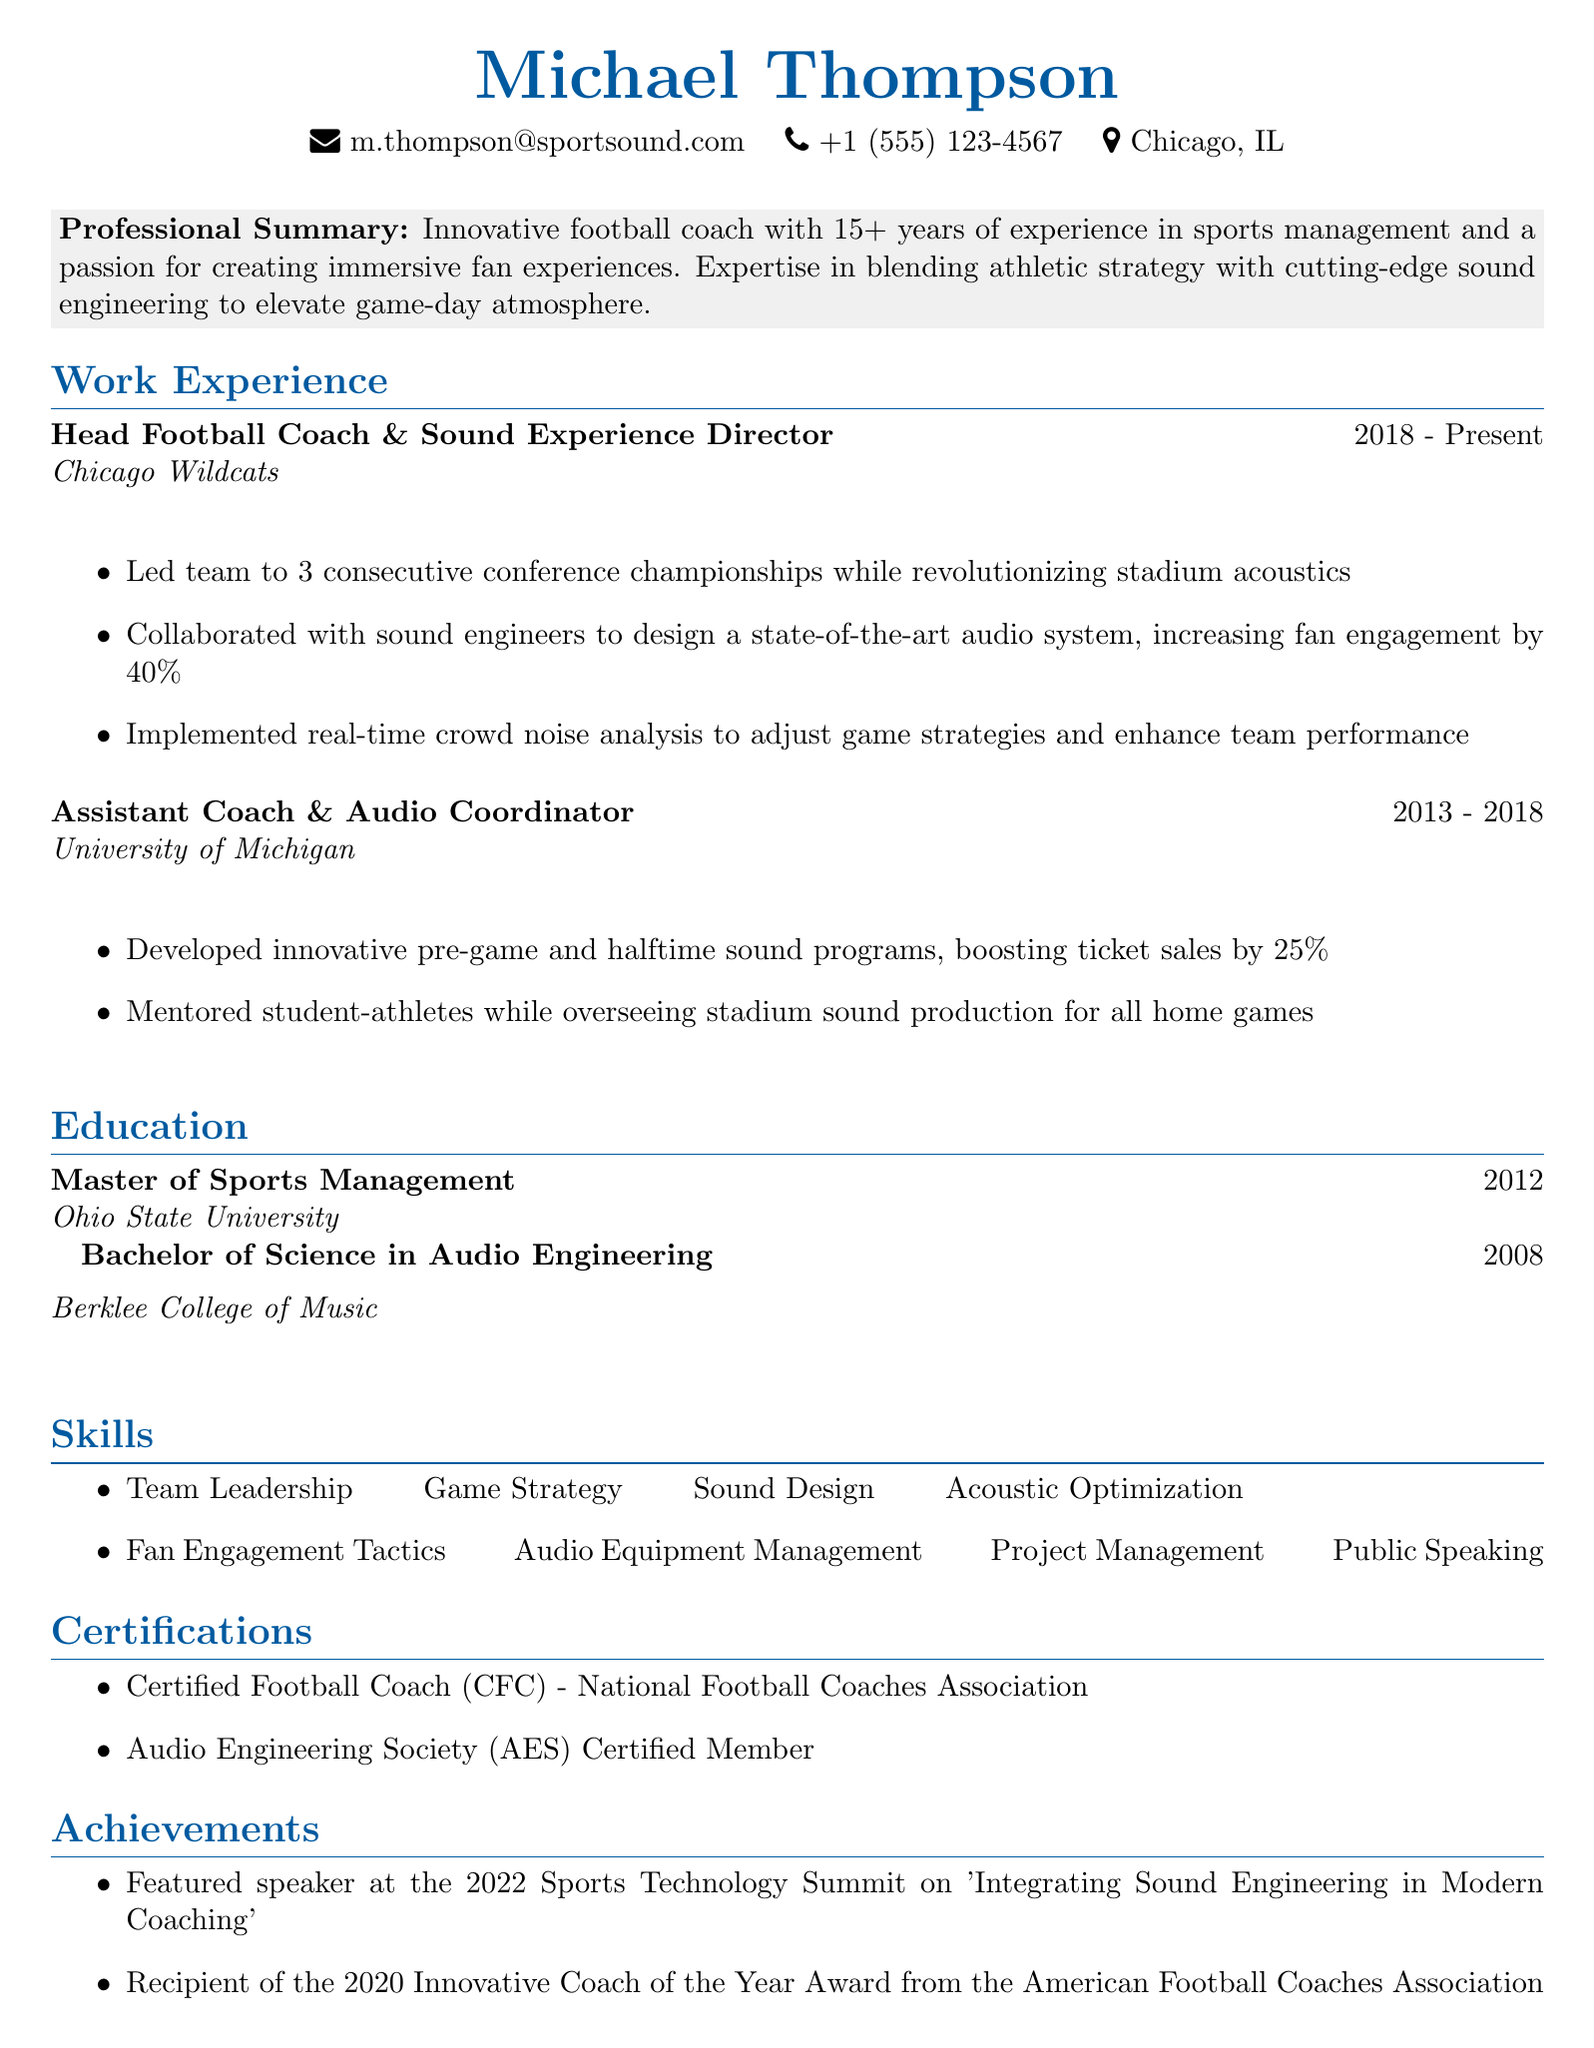What is the name of the individual? The document lists the name of the individual at the beginning as Michael Thompson.
Answer: Michael Thompson What is the email address provided? The email address is included in the personal information section of the document as m.thompson@sportsound.com.
Answer: m.thompson@sportsound.com Which organization did Michael Thompson work for as the Head Football Coach? The document specifies that he worked for the Chicago Wildcats in this role.
Answer: Chicago Wildcats How many conference championships did he lead his team to? The achievements section states that he led the team to 3 consecutive conference championships.
Answer: 3 What degree did he earn from Berklee College of Music? The education section describes that he obtained a Bachelor of Science in Audio Engineering from Berklee College of Music.
Answer: Bachelor of Science in Audio Engineering What was one of Michael Thompson's roles at the University of Michigan? The document identifies his role as Assistant Coach & Audio Coordinator at the University of Michigan.
Answer: Assistant Coach & Audio Coordinator In what year was he awarded the Innovative Coach of the Year Award? According to the achievements section, this award was received in 2020.
Answer: 2020 How much did ticket sales increase due to his innovative sound programs? The document mentions a 25% increase in ticket sales attributed to these programs.
Answer: 25% What skill is listed first in the skills section? The skills section lists Team Leadership as the first skill.
Answer: Team Leadership 